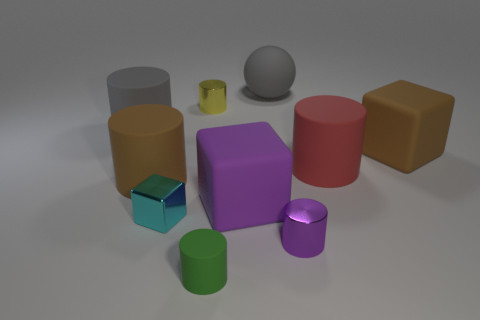What size is the red matte cylinder?
Make the answer very short. Large. What material is the big gray thing that is left of the tiny metallic cylinder that is behind the brown matte object on the right side of the green cylinder?
Your response must be concise. Rubber. How many other things are the same color as the ball?
Provide a succinct answer. 1. How many brown objects are large cubes or balls?
Make the answer very short. 1. There is a big brown object in front of the big red matte thing; what is it made of?
Offer a terse response. Rubber. Are the large brown object that is on the right side of the green thing and the red object made of the same material?
Your answer should be very brief. Yes. What is the shape of the big red rubber object?
Your answer should be compact. Cylinder. How many big brown things are right of the large block in front of the brown matte thing to the right of the tiny cube?
Make the answer very short. 1. What number of other things are the same material as the large red object?
Ensure brevity in your answer.  6. There is a cyan cube that is the same size as the yellow cylinder; what is it made of?
Make the answer very short. Metal. 